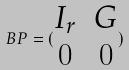<formula> <loc_0><loc_0><loc_500><loc_500>B P = ( \begin{matrix} I _ { r } & G \\ 0 & 0 \end{matrix} )</formula> 